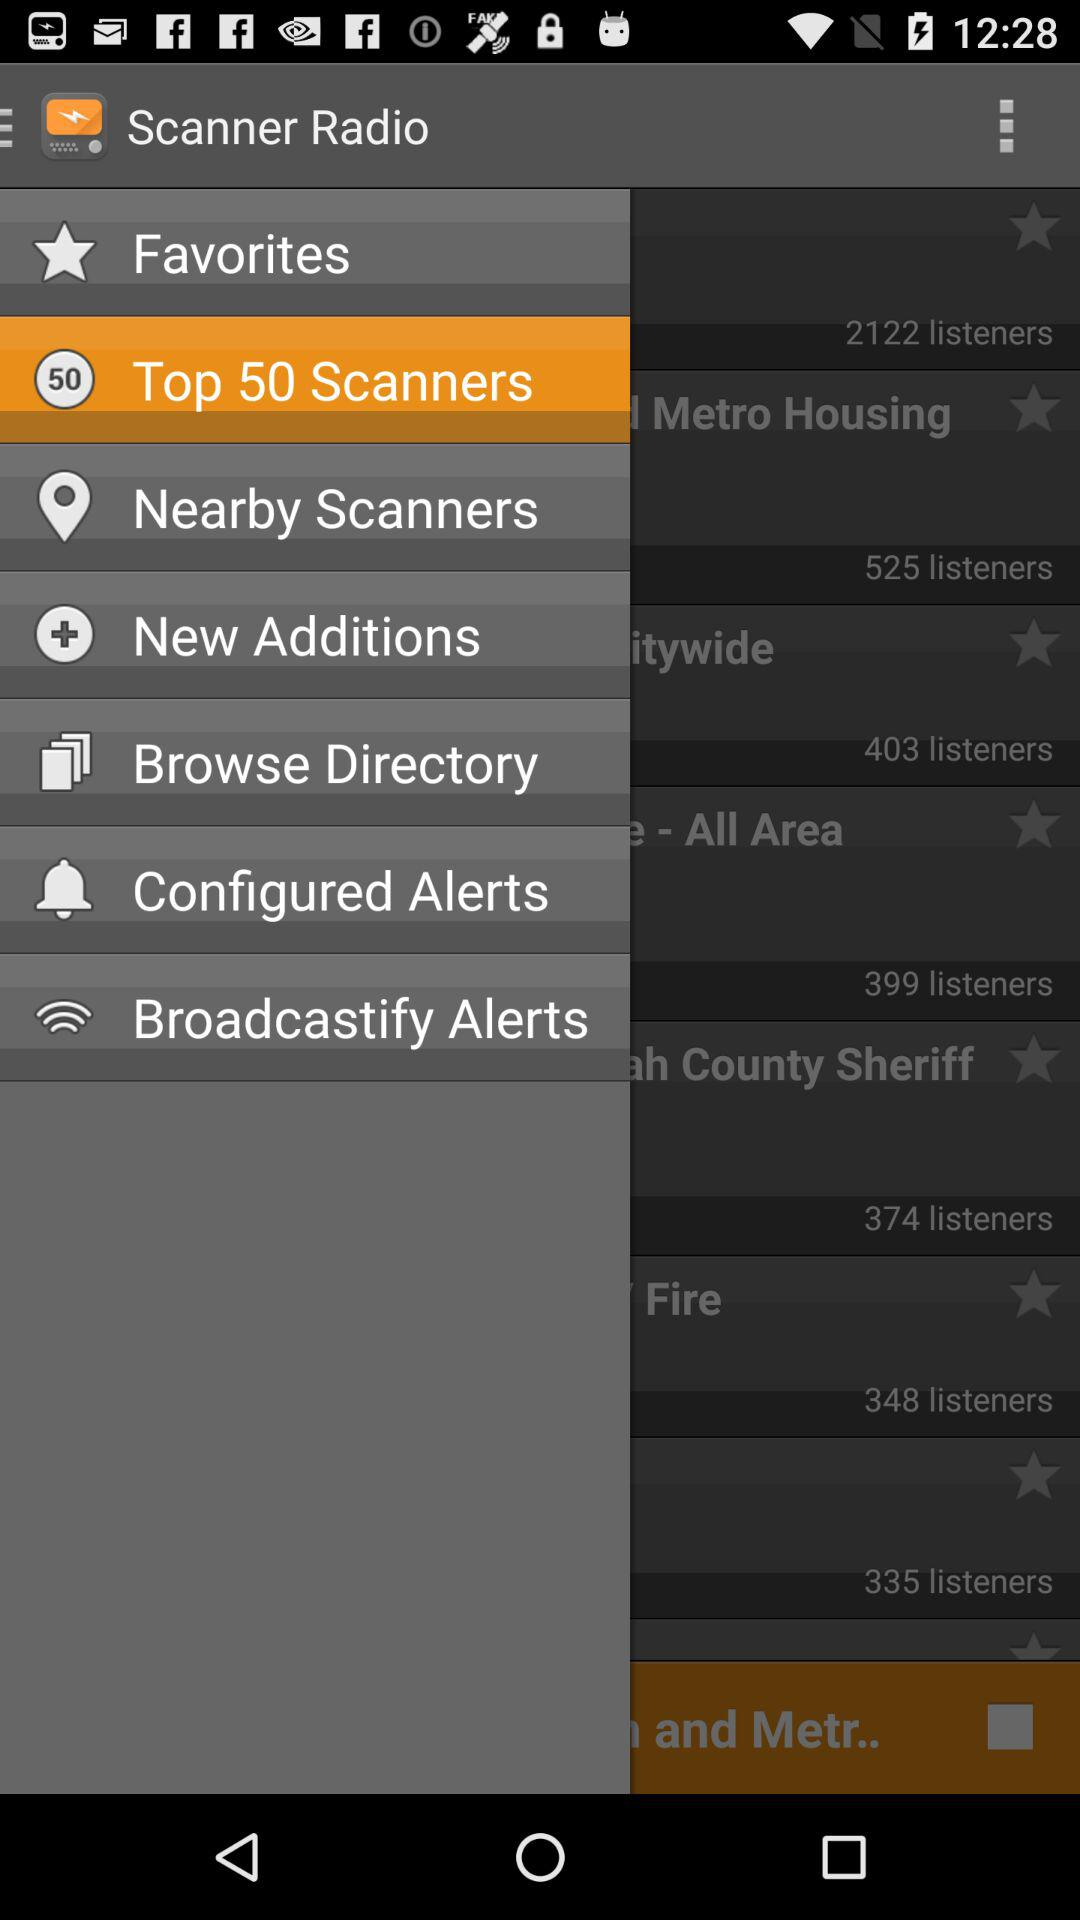What is the name of the application? The name of the application is "Scanner Radio". 